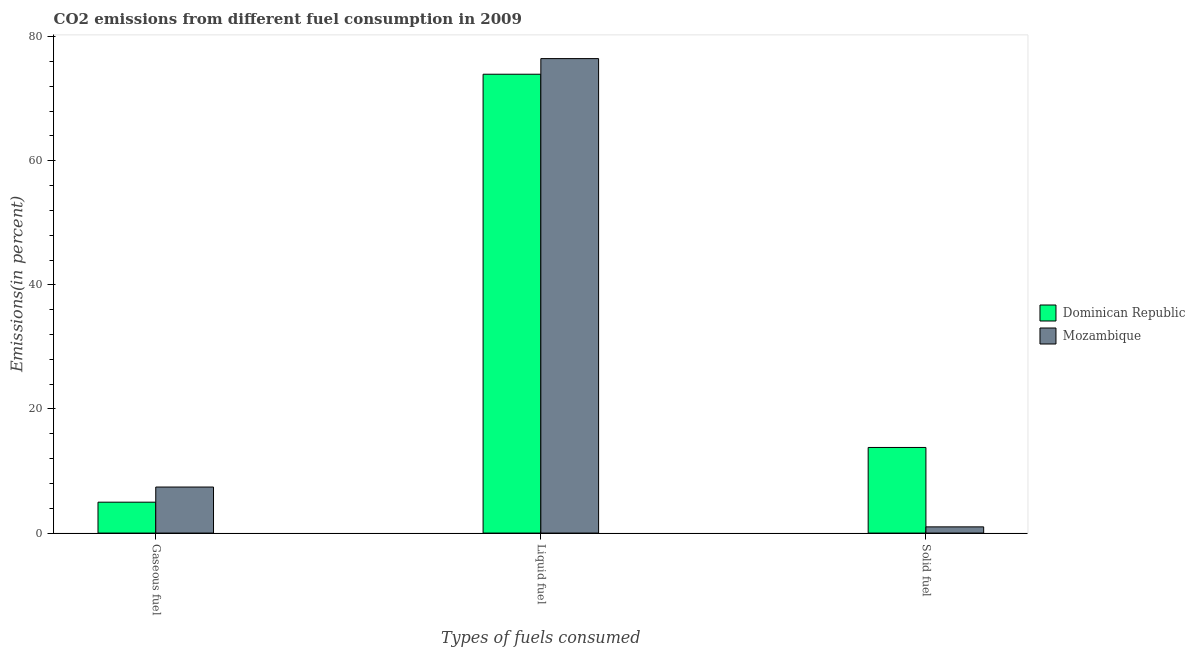How many different coloured bars are there?
Ensure brevity in your answer.  2. How many groups of bars are there?
Ensure brevity in your answer.  3. What is the label of the 2nd group of bars from the left?
Ensure brevity in your answer.  Liquid fuel. What is the percentage of liquid fuel emission in Dominican Republic?
Your answer should be compact. 73.94. Across all countries, what is the maximum percentage of liquid fuel emission?
Keep it short and to the point. 76.46. Across all countries, what is the minimum percentage of gaseous fuel emission?
Keep it short and to the point. 4.98. In which country was the percentage of gaseous fuel emission maximum?
Provide a short and direct response. Mozambique. In which country was the percentage of solid fuel emission minimum?
Ensure brevity in your answer.  Mozambique. What is the total percentage of gaseous fuel emission in the graph?
Provide a succinct answer. 12.4. What is the difference between the percentage of gaseous fuel emission in Dominican Republic and that in Mozambique?
Your response must be concise. -2.44. What is the difference between the percentage of gaseous fuel emission in Mozambique and the percentage of solid fuel emission in Dominican Republic?
Your response must be concise. -6.38. What is the average percentage of solid fuel emission per country?
Ensure brevity in your answer.  7.4. What is the difference between the percentage of gaseous fuel emission and percentage of solid fuel emission in Mozambique?
Make the answer very short. 6.42. In how many countries, is the percentage of liquid fuel emission greater than 16 %?
Provide a short and direct response. 2. What is the ratio of the percentage of solid fuel emission in Dominican Republic to that in Mozambique?
Your answer should be compact. 13.82. Is the percentage of liquid fuel emission in Mozambique less than that in Dominican Republic?
Make the answer very short. No. Is the difference between the percentage of solid fuel emission in Dominican Republic and Mozambique greater than the difference between the percentage of gaseous fuel emission in Dominican Republic and Mozambique?
Make the answer very short. Yes. What is the difference between the highest and the second highest percentage of liquid fuel emission?
Keep it short and to the point. 2.52. What is the difference between the highest and the lowest percentage of gaseous fuel emission?
Offer a very short reply. 2.44. What does the 2nd bar from the left in Liquid fuel represents?
Your answer should be compact. Mozambique. What does the 1st bar from the right in Liquid fuel represents?
Keep it short and to the point. Mozambique. Are the values on the major ticks of Y-axis written in scientific E-notation?
Your answer should be very brief. No. Where does the legend appear in the graph?
Your answer should be very brief. Center right. How many legend labels are there?
Provide a short and direct response. 2. How are the legend labels stacked?
Ensure brevity in your answer.  Vertical. What is the title of the graph?
Your answer should be compact. CO2 emissions from different fuel consumption in 2009. Does "Dominican Republic" appear as one of the legend labels in the graph?
Provide a succinct answer. Yes. What is the label or title of the X-axis?
Your answer should be very brief. Types of fuels consumed. What is the label or title of the Y-axis?
Your response must be concise. Emissions(in percent). What is the Emissions(in percent) of Dominican Republic in Gaseous fuel?
Ensure brevity in your answer.  4.98. What is the Emissions(in percent) in Mozambique in Gaseous fuel?
Give a very brief answer. 7.42. What is the Emissions(in percent) in Dominican Republic in Liquid fuel?
Your answer should be compact. 73.94. What is the Emissions(in percent) of Mozambique in Liquid fuel?
Keep it short and to the point. 76.46. What is the Emissions(in percent) of Dominican Republic in Solid fuel?
Offer a terse response. 13.8. What is the Emissions(in percent) in Mozambique in Solid fuel?
Offer a very short reply. 1. Across all Types of fuels consumed, what is the maximum Emissions(in percent) in Dominican Republic?
Ensure brevity in your answer.  73.94. Across all Types of fuels consumed, what is the maximum Emissions(in percent) in Mozambique?
Ensure brevity in your answer.  76.46. Across all Types of fuels consumed, what is the minimum Emissions(in percent) of Dominican Republic?
Keep it short and to the point. 4.98. Across all Types of fuels consumed, what is the minimum Emissions(in percent) in Mozambique?
Keep it short and to the point. 1. What is the total Emissions(in percent) in Dominican Republic in the graph?
Your response must be concise. 92.72. What is the total Emissions(in percent) of Mozambique in the graph?
Your response must be concise. 84.88. What is the difference between the Emissions(in percent) in Dominican Republic in Gaseous fuel and that in Liquid fuel?
Your answer should be very brief. -68.96. What is the difference between the Emissions(in percent) in Mozambique in Gaseous fuel and that in Liquid fuel?
Provide a short and direct response. -69.04. What is the difference between the Emissions(in percent) of Dominican Republic in Gaseous fuel and that in Solid fuel?
Give a very brief answer. -8.82. What is the difference between the Emissions(in percent) in Mozambique in Gaseous fuel and that in Solid fuel?
Offer a terse response. 6.42. What is the difference between the Emissions(in percent) in Dominican Republic in Liquid fuel and that in Solid fuel?
Ensure brevity in your answer.  60.15. What is the difference between the Emissions(in percent) of Mozambique in Liquid fuel and that in Solid fuel?
Give a very brief answer. 75.46. What is the difference between the Emissions(in percent) of Dominican Republic in Gaseous fuel and the Emissions(in percent) of Mozambique in Liquid fuel?
Your answer should be compact. -71.48. What is the difference between the Emissions(in percent) in Dominican Republic in Gaseous fuel and the Emissions(in percent) in Mozambique in Solid fuel?
Your answer should be very brief. 3.98. What is the difference between the Emissions(in percent) of Dominican Republic in Liquid fuel and the Emissions(in percent) of Mozambique in Solid fuel?
Offer a terse response. 72.94. What is the average Emissions(in percent) of Dominican Republic per Types of fuels consumed?
Provide a succinct answer. 30.91. What is the average Emissions(in percent) in Mozambique per Types of fuels consumed?
Ensure brevity in your answer.  28.29. What is the difference between the Emissions(in percent) of Dominican Republic and Emissions(in percent) of Mozambique in Gaseous fuel?
Your answer should be compact. -2.44. What is the difference between the Emissions(in percent) of Dominican Republic and Emissions(in percent) of Mozambique in Liquid fuel?
Keep it short and to the point. -2.52. What is the difference between the Emissions(in percent) of Dominican Republic and Emissions(in percent) of Mozambique in Solid fuel?
Offer a very short reply. 12.8. What is the ratio of the Emissions(in percent) in Dominican Republic in Gaseous fuel to that in Liquid fuel?
Your answer should be compact. 0.07. What is the ratio of the Emissions(in percent) in Mozambique in Gaseous fuel to that in Liquid fuel?
Your answer should be compact. 0.1. What is the ratio of the Emissions(in percent) of Dominican Republic in Gaseous fuel to that in Solid fuel?
Offer a very short reply. 0.36. What is the ratio of the Emissions(in percent) of Mozambique in Gaseous fuel to that in Solid fuel?
Your answer should be compact. 7.43. What is the ratio of the Emissions(in percent) of Dominican Republic in Liquid fuel to that in Solid fuel?
Ensure brevity in your answer.  5.36. What is the ratio of the Emissions(in percent) in Mozambique in Liquid fuel to that in Solid fuel?
Keep it short and to the point. 76.57. What is the difference between the highest and the second highest Emissions(in percent) of Dominican Republic?
Provide a succinct answer. 60.15. What is the difference between the highest and the second highest Emissions(in percent) of Mozambique?
Your answer should be very brief. 69.04. What is the difference between the highest and the lowest Emissions(in percent) in Dominican Republic?
Offer a terse response. 68.96. What is the difference between the highest and the lowest Emissions(in percent) of Mozambique?
Keep it short and to the point. 75.46. 